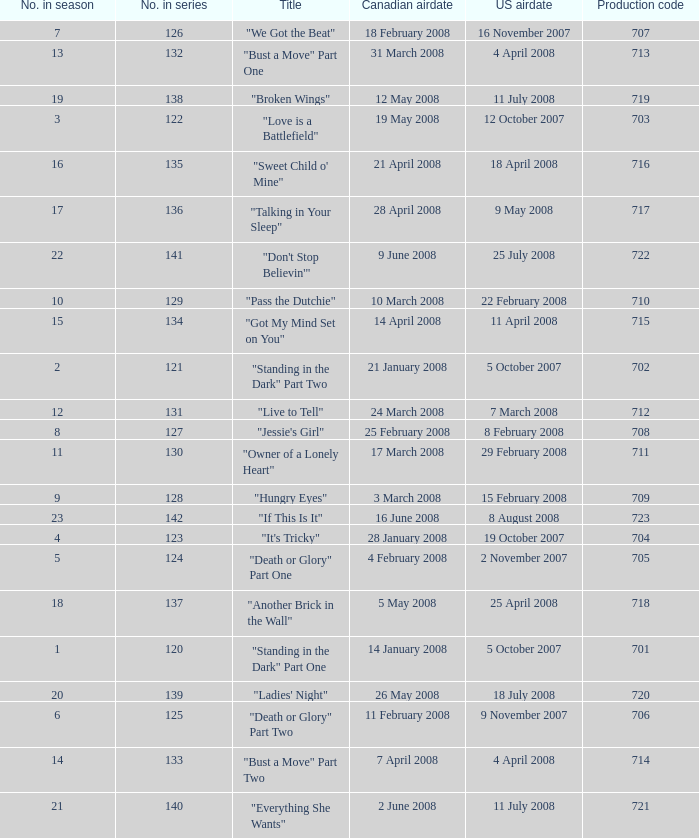The U.S. airdate of 4 april 2008 had a production code of what? 714.0. 